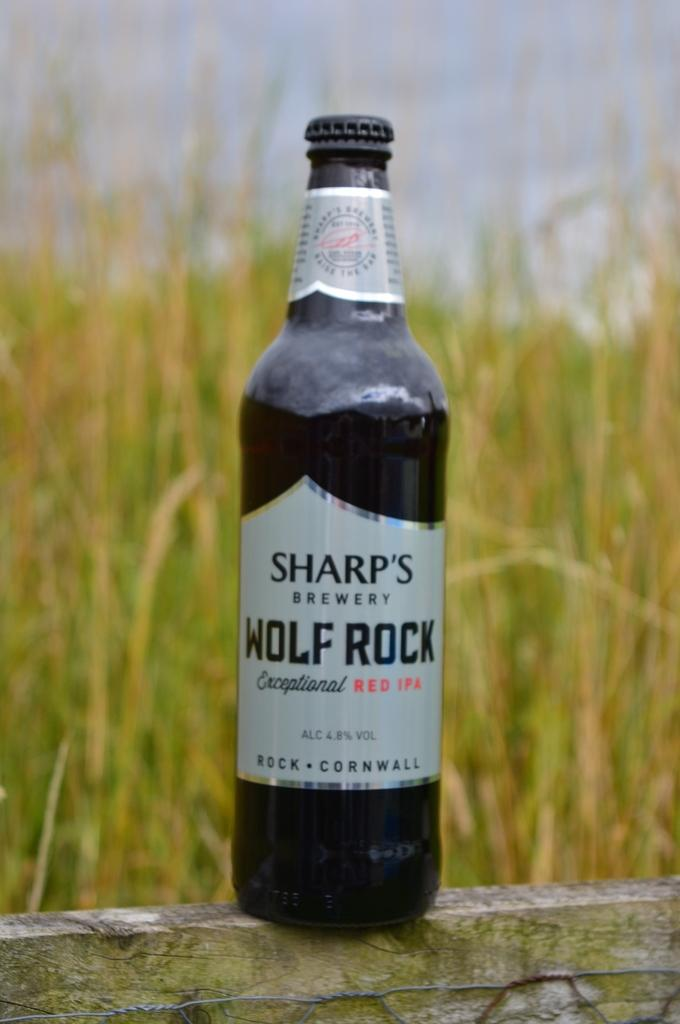<image>
Write a terse but informative summary of the picture. Black bottle with a white label that says Wolf Rock. 